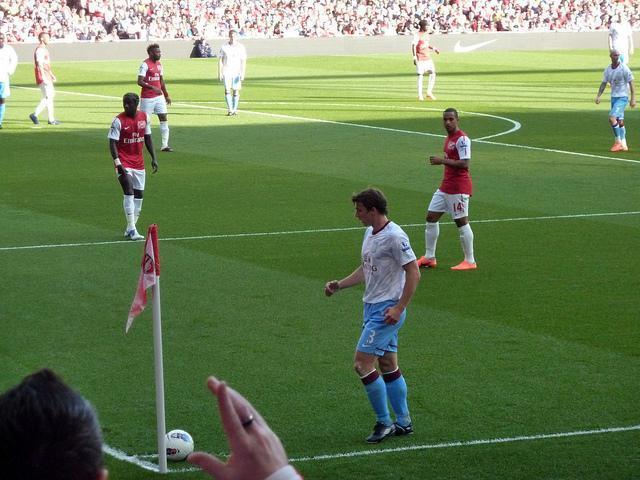How many people can you see?
Give a very brief answer. 6. How many elephants are in the water?
Give a very brief answer. 0. 